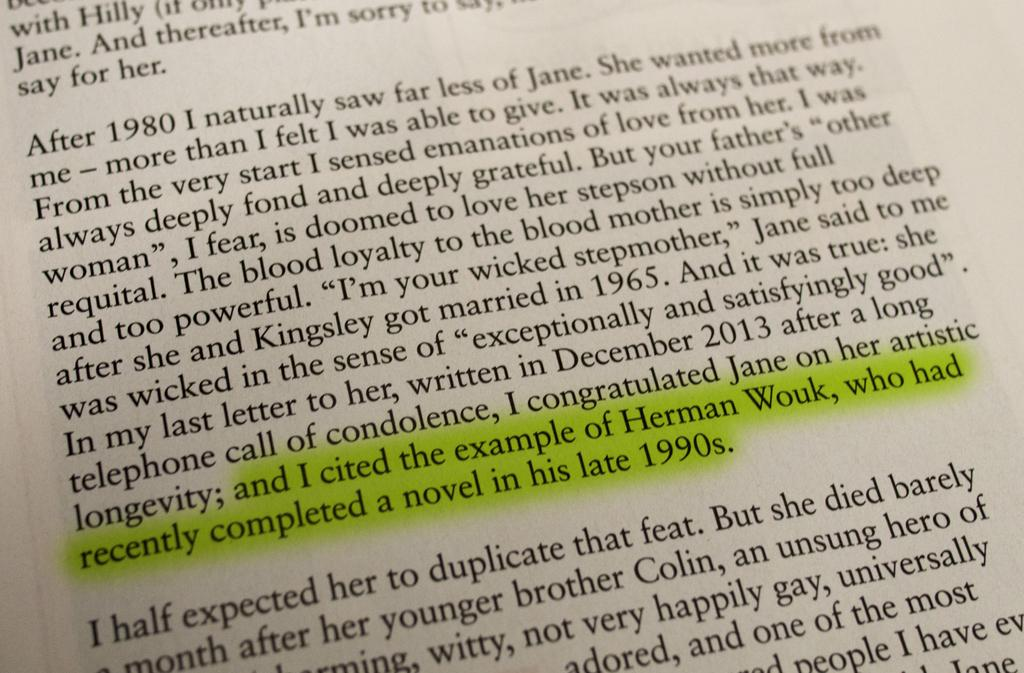What is present in the image that has text on it? There is a paper in the image that has text on it. Can you describe the text on the paper? Unfortunately, the specific content of the text cannot be determined from the image alone. What is the primary purpose of the paper in the image? The primary purpose of the paper in the image is to convey information through the text. What direction is the sail pointing in the image? There is no sail present in the image. Does the existence of the paper in the image prove the existence of a higher power? The existence of the paper in the image does not prove the existence of a higher power, as the presence of a paper is not related to the existence of a higher power. 